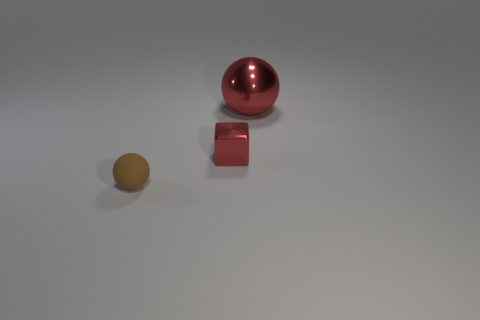Add 2 tiny green metal objects. How many objects exist? 5 Subtract all balls. How many objects are left? 1 Subtract 0 purple cylinders. How many objects are left? 3 Subtract all rubber balls. Subtract all tiny metal blocks. How many objects are left? 1 Add 1 red objects. How many red objects are left? 3 Add 3 shiny objects. How many shiny objects exist? 5 